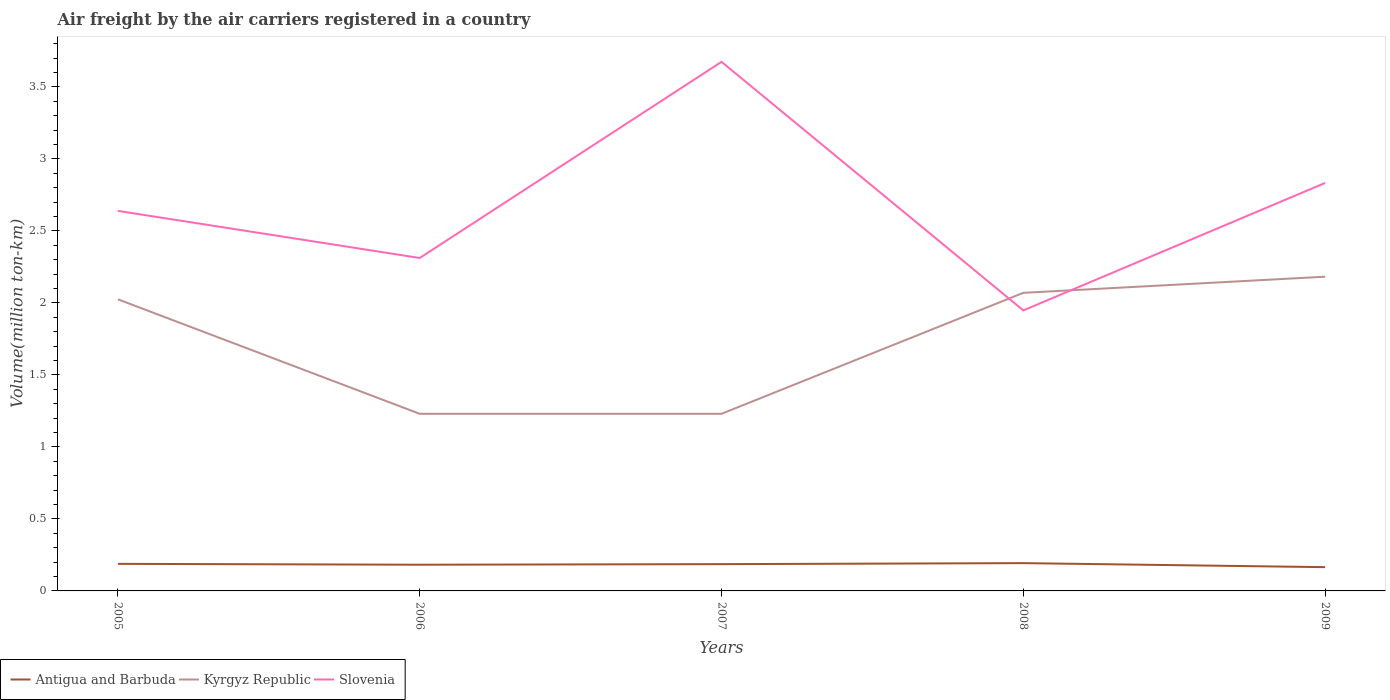Does the line corresponding to Slovenia intersect with the line corresponding to Kyrgyz Republic?
Your answer should be very brief. Yes. Is the number of lines equal to the number of legend labels?
Offer a terse response. Yes. Across all years, what is the maximum volume of the air carriers in Kyrgyz Republic?
Offer a terse response. 1.23. What is the total volume of the air carriers in Kyrgyz Republic in the graph?
Provide a succinct answer. -0.16. What is the difference between the highest and the lowest volume of the air carriers in Antigua and Barbuda?
Your answer should be compact. 3. Is the volume of the air carriers in Kyrgyz Republic strictly greater than the volume of the air carriers in Antigua and Barbuda over the years?
Offer a terse response. No. How many years are there in the graph?
Your answer should be compact. 5. What is the difference between two consecutive major ticks on the Y-axis?
Your response must be concise. 0.5. Does the graph contain any zero values?
Provide a short and direct response. No. Does the graph contain grids?
Offer a terse response. No. What is the title of the graph?
Keep it short and to the point. Air freight by the air carriers registered in a country. Does "Cameroon" appear as one of the legend labels in the graph?
Make the answer very short. No. What is the label or title of the Y-axis?
Make the answer very short. Volume(million ton-km). What is the Volume(million ton-km) in Antigua and Barbuda in 2005?
Keep it short and to the point. 0.19. What is the Volume(million ton-km) of Kyrgyz Republic in 2005?
Make the answer very short. 2.02. What is the Volume(million ton-km) of Slovenia in 2005?
Your answer should be very brief. 2.64. What is the Volume(million ton-km) in Antigua and Barbuda in 2006?
Your response must be concise. 0.18. What is the Volume(million ton-km) in Kyrgyz Republic in 2006?
Ensure brevity in your answer.  1.23. What is the Volume(million ton-km) in Slovenia in 2006?
Your answer should be compact. 2.31. What is the Volume(million ton-km) of Antigua and Barbuda in 2007?
Ensure brevity in your answer.  0.19. What is the Volume(million ton-km) in Kyrgyz Republic in 2007?
Make the answer very short. 1.23. What is the Volume(million ton-km) in Slovenia in 2007?
Provide a succinct answer. 3.67. What is the Volume(million ton-km) of Antigua and Barbuda in 2008?
Give a very brief answer. 0.19. What is the Volume(million ton-km) of Kyrgyz Republic in 2008?
Offer a very short reply. 2.07. What is the Volume(million ton-km) of Slovenia in 2008?
Your answer should be very brief. 1.95. What is the Volume(million ton-km) in Antigua and Barbuda in 2009?
Provide a short and direct response. 0.17. What is the Volume(million ton-km) in Kyrgyz Republic in 2009?
Keep it short and to the point. 2.18. What is the Volume(million ton-km) of Slovenia in 2009?
Offer a very short reply. 2.83. Across all years, what is the maximum Volume(million ton-km) of Antigua and Barbuda?
Your answer should be very brief. 0.19. Across all years, what is the maximum Volume(million ton-km) in Kyrgyz Republic?
Provide a succinct answer. 2.18. Across all years, what is the maximum Volume(million ton-km) in Slovenia?
Your answer should be very brief. 3.67. Across all years, what is the minimum Volume(million ton-km) of Antigua and Barbuda?
Provide a succinct answer. 0.17. Across all years, what is the minimum Volume(million ton-km) of Kyrgyz Republic?
Ensure brevity in your answer.  1.23. Across all years, what is the minimum Volume(million ton-km) of Slovenia?
Offer a terse response. 1.95. What is the total Volume(million ton-km) of Antigua and Barbuda in the graph?
Provide a succinct answer. 0.91. What is the total Volume(million ton-km) in Kyrgyz Republic in the graph?
Offer a terse response. 8.74. What is the total Volume(million ton-km) of Slovenia in the graph?
Make the answer very short. 13.41. What is the difference between the Volume(million ton-km) in Antigua and Barbuda in 2005 and that in 2006?
Provide a succinct answer. 0.01. What is the difference between the Volume(million ton-km) in Kyrgyz Republic in 2005 and that in 2006?
Provide a succinct answer. 0.8. What is the difference between the Volume(million ton-km) of Slovenia in 2005 and that in 2006?
Your response must be concise. 0.33. What is the difference between the Volume(million ton-km) of Antigua and Barbuda in 2005 and that in 2007?
Provide a succinct answer. 0. What is the difference between the Volume(million ton-km) of Kyrgyz Republic in 2005 and that in 2007?
Offer a very short reply. 0.8. What is the difference between the Volume(million ton-km) of Slovenia in 2005 and that in 2007?
Your answer should be very brief. -1.03. What is the difference between the Volume(million ton-km) in Antigua and Barbuda in 2005 and that in 2008?
Ensure brevity in your answer.  -0.01. What is the difference between the Volume(million ton-km) in Kyrgyz Republic in 2005 and that in 2008?
Your response must be concise. -0.04. What is the difference between the Volume(million ton-km) of Slovenia in 2005 and that in 2008?
Your answer should be very brief. 0.69. What is the difference between the Volume(million ton-km) of Antigua and Barbuda in 2005 and that in 2009?
Keep it short and to the point. 0.02. What is the difference between the Volume(million ton-km) in Kyrgyz Republic in 2005 and that in 2009?
Provide a succinct answer. -0.16. What is the difference between the Volume(million ton-km) of Slovenia in 2005 and that in 2009?
Give a very brief answer. -0.19. What is the difference between the Volume(million ton-km) of Antigua and Barbuda in 2006 and that in 2007?
Give a very brief answer. -0. What is the difference between the Volume(million ton-km) of Slovenia in 2006 and that in 2007?
Give a very brief answer. -1.36. What is the difference between the Volume(million ton-km) of Antigua and Barbuda in 2006 and that in 2008?
Offer a very short reply. -0.01. What is the difference between the Volume(million ton-km) of Kyrgyz Republic in 2006 and that in 2008?
Offer a very short reply. -0.84. What is the difference between the Volume(million ton-km) of Slovenia in 2006 and that in 2008?
Provide a short and direct response. 0.36. What is the difference between the Volume(million ton-km) of Antigua and Barbuda in 2006 and that in 2009?
Offer a very short reply. 0.02. What is the difference between the Volume(million ton-km) of Kyrgyz Republic in 2006 and that in 2009?
Your response must be concise. -0.95. What is the difference between the Volume(million ton-km) in Slovenia in 2006 and that in 2009?
Your response must be concise. -0.52. What is the difference between the Volume(million ton-km) in Antigua and Barbuda in 2007 and that in 2008?
Ensure brevity in your answer.  -0.01. What is the difference between the Volume(million ton-km) in Kyrgyz Republic in 2007 and that in 2008?
Provide a short and direct response. -0.84. What is the difference between the Volume(million ton-km) in Slovenia in 2007 and that in 2008?
Offer a terse response. 1.73. What is the difference between the Volume(million ton-km) in Antigua and Barbuda in 2007 and that in 2009?
Your answer should be very brief. 0.02. What is the difference between the Volume(million ton-km) of Kyrgyz Republic in 2007 and that in 2009?
Your response must be concise. -0.95. What is the difference between the Volume(million ton-km) of Slovenia in 2007 and that in 2009?
Offer a very short reply. 0.84. What is the difference between the Volume(million ton-km) in Antigua and Barbuda in 2008 and that in 2009?
Keep it short and to the point. 0.03. What is the difference between the Volume(million ton-km) of Kyrgyz Republic in 2008 and that in 2009?
Your response must be concise. -0.11. What is the difference between the Volume(million ton-km) in Slovenia in 2008 and that in 2009?
Provide a succinct answer. -0.89. What is the difference between the Volume(million ton-km) in Antigua and Barbuda in 2005 and the Volume(million ton-km) in Kyrgyz Republic in 2006?
Offer a very short reply. -1.04. What is the difference between the Volume(million ton-km) of Antigua and Barbuda in 2005 and the Volume(million ton-km) of Slovenia in 2006?
Provide a short and direct response. -2.12. What is the difference between the Volume(million ton-km) of Kyrgyz Republic in 2005 and the Volume(million ton-km) of Slovenia in 2006?
Give a very brief answer. -0.29. What is the difference between the Volume(million ton-km) in Antigua and Barbuda in 2005 and the Volume(million ton-km) in Kyrgyz Republic in 2007?
Give a very brief answer. -1.04. What is the difference between the Volume(million ton-km) in Antigua and Barbuda in 2005 and the Volume(million ton-km) in Slovenia in 2007?
Offer a very short reply. -3.49. What is the difference between the Volume(million ton-km) of Kyrgyz Republic in 2005 and the Volume(million ton-km) of Slovenia in 2007?
Your answer should be compact. -1.65. What is the difference between the Volume(million ton-km) of Antigua and Barbuda in 2005 and the Volume(million ton-km) of Kyrgyz Republic in 2008?
Your answer should be compact. -1.88. What is the difference between the Volume(million ton-km) of Antigua and Barbuda in 2005 and the Volume(million ton-km) of Slovenia in 2008?
Provide a short and direct response. -1.76. What is the difference between the Volume(million ton-km) in Kyrgyz Republic in 2005 and the Volume(million ton-km) in Slovenia in 2008?
Offer a very short reply. 0.08. What is the difference between the Volume(million ton-km) of Antigua and Barbuda in 2005 and the Volume(million ton-km) of Kyrgyz Republic in 2009?
Your answer should be compact. -1.99. What is the difference between the Volume(million ton-km) of Antigua and Barbuda in 2005 and the Volume(million ton-km) of Slovenia in 2009?
Keep it short and to the point. -2.65. What is the difference between the Volume(million ton-km) of Kyrgyz Republic in 2005 and the Volume(million ton-km) of Slovenia in 2009?
Provide a short and direct response. -0.81. What is the difference between the Volume(million ton-km) of Antigua and Barbuda in 2006 and the Volume(million ton-km) of Kyrgyz Republic in 2007?
Give a very brief answer. -1.05. What is the difference between the Volume(million ton-km) of Antigua and Barbuda in 2006 and the Volume(million ton-km) of Slovenia in 2007?
Offer a very short reply. -3.49. What is the difference between the Volume(million ton-km) in Kyrgyz Republic in 2006 and the Volume(million ton-km) in Slovenia in 2007?
Provide a succinct answer. -2.44. What is the difference between the Volume(million ton-km) of Antigua and Barbuda in 2006 and the Volume(million ton-km) of Kyrgyz Republic in 2008?
Provide a succinct answer. -1.89. What is the difference between the Volume(million ton-km) in Antigua and Barbuda in 2006 and the Volume(million ton-km) in Slovenia in 2008?
Your answer should be compact. -1.77. What is the difference between the Volume(million ton-km) of Kyrgyz Republic in 2006 and the Volume(million ton-km) of Slovenia in 2008?
Give a very brief answer. -0.72. What is the difference between the Volume(million ton-km) of Antigua and Barbuda in 2006 and the Volume(million ton-km) of Kyrgyz Republic in 2009?
Your answer should be compact. -2. What is the difference between the Volume(million ton-km) in Antigua and Barbuda in 2006 and the Volume(million ton-km) in Slovenia in 2009?
Keep it short and to the point. -2.65. What is the difference between the Volume(million ton-km) of Kyrgyz Republic in 2006 and the Volume(million ton-km) of Slovenia in 2009?
Make the answer very short. -1.6. What is the difference between the Volume(million ton-km) in Antigua and Barbuda in 2007 and the Volume(million ton-km) in Kyrgyz Republic in 2008?
Make the answer very short. -1.88. What is the difference between the Volume(million ton-km) in Antigua and Barbuda in 2007 and the Volume(million ton-km) in Slovenia in 2008?
Your response must be concise. -1.76. What is the difference between the Volume(million ton-km) of Kyrgyz Republic in 2007 and the Volume(million ton-km) of Slovenia in 2008?
Your answer should be very brief. -0.72. What is the difference between the Volume(million ton-km) in Antigua and Barbuda in 2007 and the Volume(million ton-km) in Kyrgyz Republic in 2009?
Your response must be concise. -2. What is the difference between the Volume(million ton-km) of Antigua and Barbuda in 2007 and the Volume(million ton-km) of Slovenia in 2009?
Your answer should be very brief. -2.65. What is the difference between the Volume(million ton-km) of Kyrgyz Republic in 2007 and the Volume(million ton-km) of Slovenia in 2009?
Ensure brevity in your answer.  -1.6. What is the difference between the Volume(million ton-km) in Antigua and Barbuda in 2008 and the Volume(million ton-km) in Kyrgyz Republic in 2009?
Offer a very short reply. -1.99. What is the difference between the Volume(million ton-km) of Antigua and Barbuda in 2008 and the Volume(million ton-km) of Slovenia in 2009?
Give a very brief answer. -2.64. What is the difference between the Volume(million ton-km) in Kyrgyz Republic in 2008 and the Volume(million ton-km) in Slovenia in 2009?
Provide a short and direct response. -0.76. What is the average Volume(million ton-km) in Antigua and Barbuda per year?
Provide a short and direct response. 0.18. What is the average Volume(million ton-km) of Kyrgyz Republic per year?
Your answer should be compact. 1.75. What is the average Volume(million ton-km) in Slovenia per year?
Keep it short and to the point. 2.68. In the year 2005, what is the difference between the Volume(million ton-km) in Antigua and Barbuda and Volume(million ton-km) in Kyrgyz Republic?
Provide a succinct answer. -1.84. In the year 2005, what is the difference between the Volume(million ton-km) of Antigua and Barbuda and Volume(million ton-km) of Slovenia?
Provide a short and direct response. -2.45. In the year 2005, what is the difference between the Volume(million ton-km) of Kyrgyz Republic and Volume(million ton-km) of Slovenia?
Give a very brief answer. -0.61. In the year 2006, what is the difference between the Volume(million ton-km) in Antigua and Barbuda and Volume(million ton-km) in Kyrgyz Republic?
Offer a very short reply. -1.05. In the year 2006, what is the difference between the Volume(million ton-km) in Antigua and Barbuda and Volume(million ton-km) in Slovenia?
Offer a terse response. -2.13. In the year 2006, what is the difference between the Volume(million ton-km) in Kyrgyz Republic and Volume(million ton-km) in Slovenia?
Keep it short and to the point. -1.08. In the year 2007, what is the difference between the Volume(million ton-km) of Antigua and Barbuda and Volume(million ton-km) of Kyrgyz Republic?
Make the answer very short. -1.04. In the year 2007, what is the difference between the Volume(million ton-km) in Antigua and Barbuda and Volume(million ton-km) in Slovenia?
Your response must be concise. -3.49. In the year 2007, what is the difference between the Volume(million ton-km) in Kyrgyz Republic and Volume(million ton-km) in Slovenia?
Ensure brevity in your answer.  -2.44. In the year 2008, what is the difference between the Volume(million ton-km) in Antigua and Barbuda and Volume(million ton-km) in Kyrgyz Republic?
Give a very brief answer. -1.88. In the year 2008, what is the difference between the Volume(million ton-km) in Antigua and Barbuda and Volume(million ton-km) in Slovenia?
Your answer should be compact. -1.75. In the year 2008, what is the difference between the Volume(million ton-km) of Kyrgyz Republic and Volume(million ton-km) of Slovenia?
Ensure brevity in your answer.  0.12. In the year 2009, what is the difference between the Volume(million ton-km) in Antigua and Barbuda and Volume(million ton-km) in Kyrgyz Republic?
Keep it short and to the point. -2.02. In the year 2009, what is the difference between the Volume(million ton-km) of Antigua and Barbuda and Volume(million ton-km) of Slovenia?
Make the answer very short. -2.67. In the year 2009, what is the difference between the Volume(million ton-km) of Kyrgyz Republic and Volume(million ton-km) of Slovenia?
Give a very brief answer. -0.65. What is the ratio of the Volume(million ton-km) in Antigua and Barbuda in 2005 to that in 2006?
Keep it short and to the point. 1.03. What is the ratio of the Volume(million ton-km) in Kyrgyz Republic in 2005 to that in 2006?
Your answer should be compact. 1.65. What is the ratio of the Volume(million ton-km) in Slovenia in 2005 to that in 2006?
Your answer should be compact. 1.14. What is the ratio of the Volume(million ton-km) of Antigua and Barbuda in 2005 to that in 2007?
Your answer should be compact. 1.01. What is the ratio of the Volume(million ton-km) of Kyrgyz Republic in 2005 to that in 2007?
Provide a succinct answer. 1.65. What is the ratio of the Volume(million ton-km) of Slovenia in 2005 to that in 2007?
Make the answer very short. 0.72. What is the ratio of the Volume(million ton-km) of Antigua and Barbuda in 2005 to that in 2008?
Your answer should be compact. 0.97. What is the ratio of the Volume(million ton-km) of Kyrgyz Republic in 2005 to that in 2008?
Provide a short and direct response. 0.98. What is the ratio of the Volume(million ton-km) in Slovenia in 2005 to that in 2008?
Your answer should be compact. 1.35. What is the ratio of the Volume(million ton-km) in Antigua and Barbuda in 2005 to that in 2009?
Keep it short and to the point. 1.14. What is the ratio of the Volume(million ton-km) of Kyrgyz Republic in 2005 to that in 2009?
Give a very brief answer. 0.93. What is the ratio of the Volume(million ton-km) in Slovenia in 2005 to that in 2009?
Make the answer very short. 0.93. What is the ratio of the Volume(million ton-km) in Antigua and Barbuda in 2006 to that in 2007?
Provide a short and direct response. 0.98. What is the ratio of the Volume(million ton-km) of Kyrgyz Republic in 2006 to that in 2007?
Your answer should be very brief. 1. What is the ratio of the Volume(million ton-km) in Slovenia in 2006 to that in 2007?
Offer a very short reply. 0.63. What is the ratio of the Volume(million ton-km) of Antigua and Barbuda in 2006 to that in 2008?
Your answer should be very brief. 0.94. What is the ratio of the Volume(million ton-km) of Kyrgyz Republic in 2006 to that in 2008?
Ensure brevity in your answer.  0.59. What is the ratio of the Volume(million ton-km) in Slovenia in 2006 to that in 2008?
Offer a very short reply. 1.19. What is the ratio of the Volume(million ton-km) of Antigua and Barbuda in 2006 to that in 2009?
Ensure brevity in your answer.  1.1. What is the ratio of the Volume(million ton-km) in Kyrgyz Republic in 2006 to that in 2009?
Your response must be concise. 0.56. What is the ratio of the Volume(million ton-km) in Slovenia in 2006 to that in 2009?
Your response must be concise. 0.82. What is the ratio of the Volume(million ton-km) of Antigua and Barbuda in 2007 to that in 2008?
Provide a succinct answer. 0.96. What is the ratio of the Volume(million ton-km) in Kyrgyz Republic in 2007 to that in 2008?
Keep it short and to the point. 0.59. What is the ratio of the Volume(million ton-km) in Slovenia in 2007 to that in 2008?
Provide a short and direct response. 1.89. What is the ratio of the Volume(million ton-km) of Antigua and Barbuda in 2007 to that in 2009?
Provide a short and direct response. 1.13. What is the ratio of the Volume(million ton-km) in Kyrgyz Republic in 2007 to that in 2009?
Your answer should be compact. 0.56. What is the ratio of the Volume(million ton-km) of Slovenia in 2007 to that in 2009?
Keep it short and to the point. 1.3. What is the ratio of the Volume(million ton-km) of Antigua and Barbuda in 2008 to that in 2009?
Offer a terse response. 1.17. What is the ratio of the Volume(million ton-km) of Kyrgyz Republic in 2008 to that in 2009?
Give a very brief answer. 0.95. What is the ratio of the Volume(million ton-km) of Slovenia in 2008 to that in 2009?
Your response must be concise. 0.69. What is the difference between the highest and the second highest Volume(million ton-km) of Antigua and Barbuda?
Ensure brevity in your answer.  0.01. What is the difference between the highest and the second highest Volume(million ton-km) of Kyrgyz Republic?
Ensure brevity in your answer.  0.11. What is the difference between the highest and the second highest Volume(million ton-km) in Slovenia?
Offer a very short reply. 0.84. What is the difference between the highest and the lowest Volume(million ton-km) of Antigua and Barbuda?
Your answer should be compact. 0.03. What is the difference between the highest and the lowest Volume(million ton-km) in Slovenia?
Your answer should be compact. 1.73. 